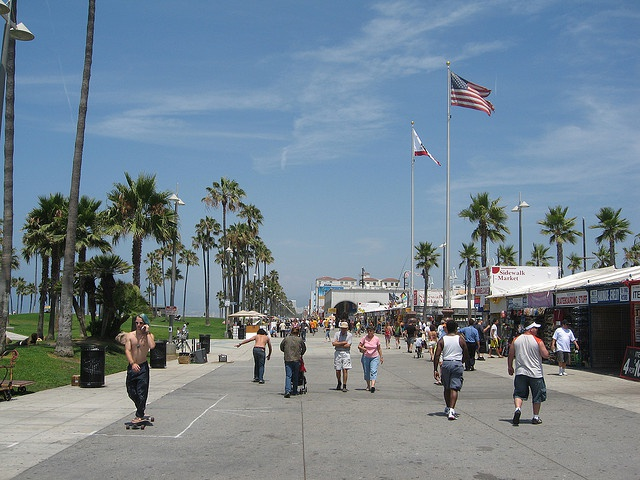Describe the objects in this image and their specific colors. I can see people in lightgray, darkgray, black, gray, and darkgreen tones, people in lightgray, black, gray, and darkgray tones, people in lightgray, black, gray, and darkgray tones, people in lightgray, black, gray, and tan tones, and people in lightgray, black, gray, and blue tones in this image. 